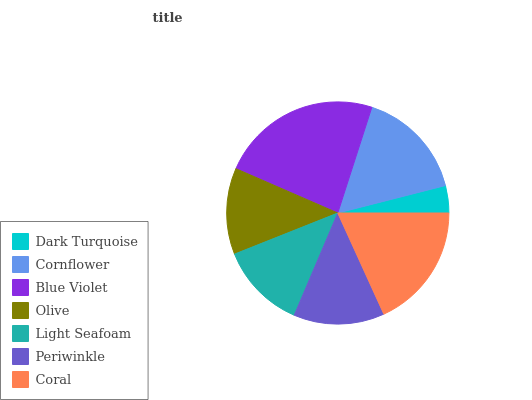Is Dark Turquoise the minimum?
Answer yes or no. Yes. Is Blue Violet the maximum?
Answer yes or no. Yes. Is Cornflower the minimum?
Answer yes or no. No. Is Cornflower the maximum?
Answer yes or no. No. Is Cornflower greater than Dark Turquoise?
Answer yes or no. Yes. Is Dark Turquoise less than Cornflower?
Answer yes or no. Yes. Is Dark Turquoise greater than Cornflower?
Answer yes or no. No. Is Cornflower less than Dark Turquoise?
Answer yes or no. No. Is Periwinkle the high median?
Answer yes or no. Yes. Is Periwinkle the low median?
Answer yes or no. Yes. Is Dark Turquoise the high median?
Answer yes or no. No. Is Cornflower the low median?
Answer yes or no. No. 